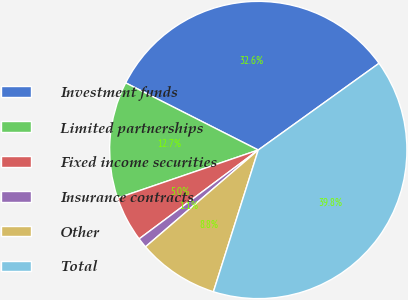Convert chart. <chart><loc_0><loc_0><loc_500><loc_500><pie_chart><fcel>Investment funds<fcel>Limited partnerships<fcel>Fixed income securities<fcel>Insurance contracts<fcel>Other<fcel>Total<nl><fcel>32.63%<fcel>12.7%<fcel>4.96%<fcel>1.09%<fcel>8.83%<fcel>39.79%<nl></chart> 